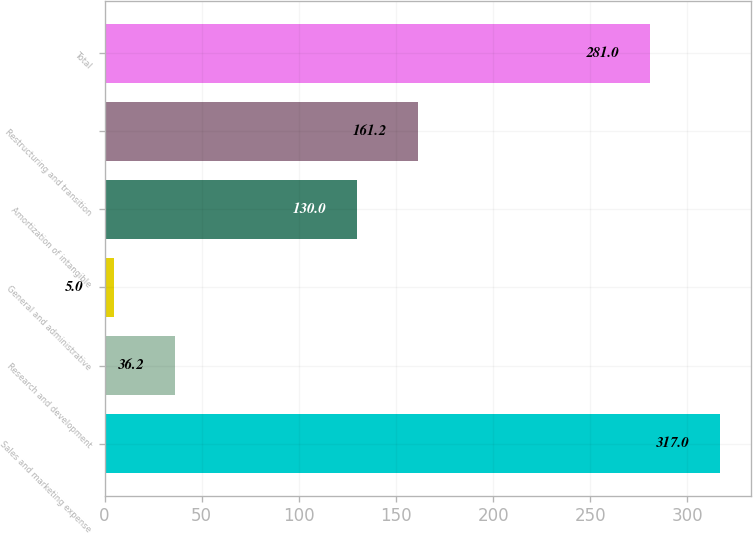Convert chart to OTSL. <chart><loc_0><loc_0><loc_500><loc_500><bar_chart><fcel>Sales and marketing expense<fcel>Research and development<fcel>General and administrative<fcel>Amortization of intangible<fcel>Restructuring and transition<fcel>Total<nl><fcel>317<fcel>36.2<fcel>5<fcel>130<fcel>161.2<fcel>281<nl></chart> 